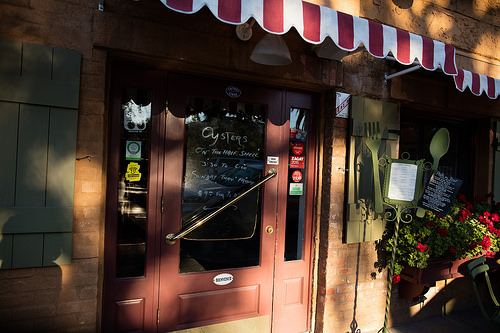<image>
Is the flowers in the restaurant? No. The flowers is not contained within the restaurant. These objects have a different spatial relationship. 